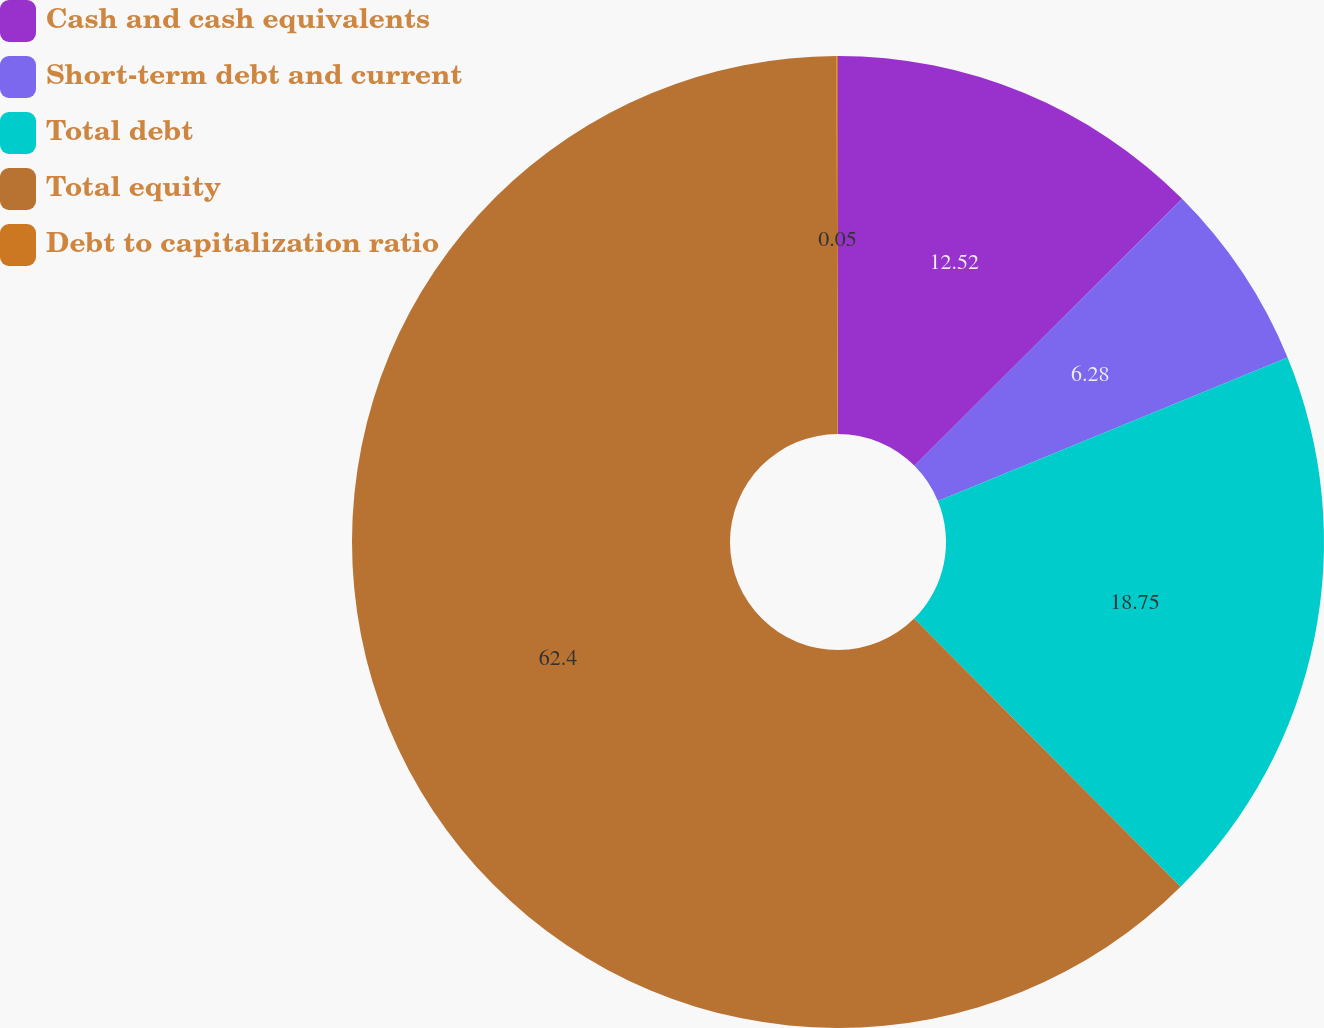<chart> <loc_0><loc_0><loc_500><loc_500><pie_chart><fcel>Cash and cash equivalents<fcel>Short-term debt and current<fcel>Total debt<fcel>Total equity<fcel>Debt to capitalization ratio<nl><fcel>12.52%<fcel>6.28%<fcel>18.75%<fcel>62.4%<fcel>0.05%<nl></chart> 